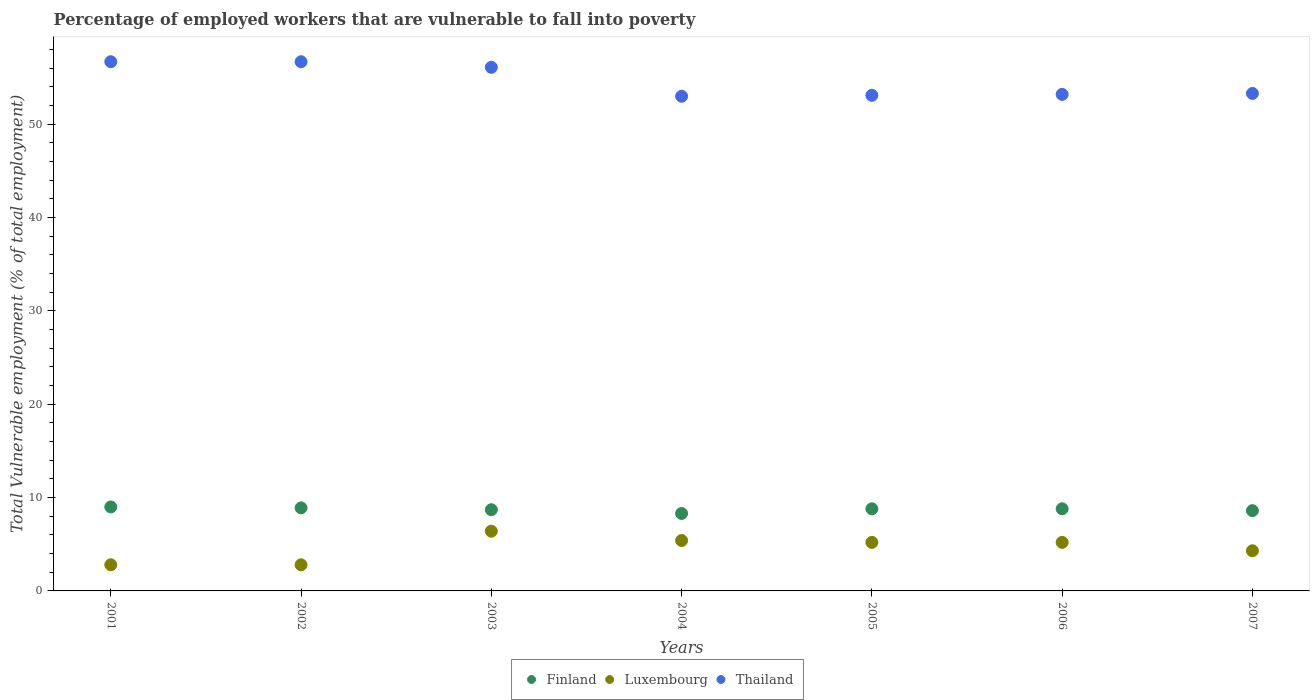How many different coloured dotlines are there?
Provide a succinct answer. 3. Is the number of dotlines equal to the number of legend labels?
Offer a terse response. Yes. What is the percentage of employed workers who are vulnerable to fall into poverty in Luxembourg in 2005?
Give a very brief answer. 5.2. Across all years, what is the maximum percentage of employed workers who are vulnerable to fall into poverty in Thailand?
Give a very brief answer. 56.7. Across all years, what is the minimum percentage of employed workers who are vulnerable to fall into poverty in Finland?
Your answer should be very brief. 8.3. What is the total percentage of employed workers who are vulnerable to fall into poverty in Luxembourg in the graph?
Ensure brevity in your answer.  32.1. What is the difference between the percentage of employed workers who are vulnerable to fall into poverty in Luxembourg in 2004 and that in 2005?
Your response must be concise. 0.2. What is the difference between the percentage of employed workers who are vulnerable to fall into poverty in Thailand in 2006 and the percentage of employed workers who are vulnerable to fall into poverty in Luxembourg in 2002?
Your response must be concise. 50.4. What is the average percentage of employed workers who are vulnerable to fall into poverty in Thailand per year?
Your answer should be compact. 54.59. In the year 2005, what is the difference between the percentage of employed workers who are vulnerable to fall into poverty in Thailand and percentage of employed workers who are vulnerable to fall into poverty in Luxembourg?
Make the answer very short. 47.9. What is the ratio of the percentage of employed workers who are vulnerable to fall into poverty in Thailand in 2006 to that in 2007?
Your answer should be very brief. 1. Is the difference between the percentage of employed workers who are vulnerable to fall into poverty in Thailand in 2001 and 2007 greater than the difference between the percentage of employed workers who are vulnerable to fall into poverty in Luxembourg in 2001 and 2007?
Offer a very short reply. Yes. What is the difference between the highest and the second highest percentage of employed workers who are vulnerable to fall into poverty in Luxembourg?
Provide a short and direct response. 1. What is the difference between the highest and the lowest percentage of employed workers who are vulnerable to fall into poverty in Thailand?
Offer a terse response. 3.7. Is the sum of the percentage of employed workers who are vulnerable to fall into poverty in Finland in 2002 and 2004 greater than the maximum percentage of employed workers who are vulnerable to fall into poverty in Thailand across all years?
Provide a short and direct response. No. Is the percentage of employed workers who are vulnerable to fall into poverty in Finland strictly greater than the percentage of employed workers who are vulnerable to fall into poverty in Thailand over the years?
Ensure brevity in your answer.  No. Is the percentage of employed workers who are vulnerable to fall into poverty in Thailand strictly less than the percentage of employed workers who are vulnerable to fall into poverty in Finland over the years?
Your answer should be compact. No. How many years are there in the graph?
Your response must be concise. 7. Are the values on the major ticks of Y-axis written in scientific E-notation?
Give a very brief answer. No. Does the graph contain any zero values?
Your answer should be compact. No. Does the graph contain grids?
Offer a terse response. No. Where does the legend appear in the graph?
Your answer should be very brief. Bottom center. How many legend labels are there?
Give a very brief answer. 3. What is the title of the graph?
Give a very brief answer. Percentage of employed workers that are vulnerable to fall into poverty. Does "Liberia" appear as one of the legend labels in the graph?
Your response must be concise. No. What is the label or title of the Y-axis?
Your answer should be compact. Total Vulnerable employment (% of total employment). What is the Total Vulnerable employment (% of total employment) of Finland in 2001?
Your answer should be compact. 9. What is the Total Vulnerable employment (% of total employment) in Luxembourg in 2001?
Keep it short and to the point. 2.8. What is the Total Vulnerable employment (% of total employment) in Thailand in 2001?
Provide a succinct answer. 56.7. What is the Total Vulnerable employment (% of total employment) in Finland in 2002?
Provide a succinct answer. 8.9. What is the Total Vulnerable employment (% of total employment) of Luxembourg in 2002?
Provide a short and direct response. 2.8. What is the Total Vulnerable employment (% of total employment) of Thailand in 2002?
Your response must be concise. 56.7. What is the Total Vulnerable employment (% of total employment) in Finland in 2003?
Offer a terse response. 8.7. What is the Total Vulnerable employment (% of total employment) in Luxembourg in 2003?
Your answer should be very brief. 6.4. What is the Total Vulnerable employment (% of total employment) of Thailand in 2003?
Offer a very short reply. 56.1. What is the Total Vulnerable employment (% of total employment) in Finland in 2004?
Your response must be concise. 8.3. What is the Total Vulnerable employment (% of total employment) in Luxembourg in 2004?
Your answer should be very brief. 5.4. What is the Total Vulnerable employment (% of total employment) of Finland in 2005?
Keep it short and to the point. 8.8. What is the Total Vulnerable employment (% of total employment) of Luxembourg in 2005?
Offer a terse response. 5.2. What is the Total Vulnerable employment (% of total employment) in Thailand in 2005?
Offer a terse response. 53.1. What is the Total Vulnerable employment (% of total employment) of Finland in 2006?
Your answer should be compact. 8.8. What is the Total Vulnerable employment (% of total employment) in Luxembourg in 2006?
Offer a terse response. 5.2. What is the Total Vulnerable employment (% of total employment) of Thailand in 2006?
Give a very brief answer. 53.2. What is the Total Vulnerable employment (% of total employment) of Finland in 2007?
Your response must be concise. 8.6. What is the Total Vulnerable employment (% of total employment) in Luxembourg in 2007?
Offer a terse response. 4.3. What is the Total Vulnerable employment (% of total employment) of Thailand in 2007?
Keep it short and to the point. 53.3. Across all years, what is the maximum Total Vulnerable employment (% of total employment) of Finland?
Your answer should be very brief. 9. Across all years, what is the maximum Total Vulnerable employment (% of total employment) of Luxembourg?
Offer a terse response. 6.4. Across all years, what is the maximum Total Vulnerable employment (% of total employment) in Thailand?
Provide a short and direct response. 56.7. Across all years, what is the minimum Total Vulnerable employment (% of total employment) in Finland?
Keep it short and to the point. 8.3. Across all years, what is the minimum Total Vulnerable employment (% of total employment) of Luxembourg?
Make the answer very short. 2.8. What is the total Total Vulnerable employment (% of total employment) of Finland in the graph?
Give a very brief answer. 61.1. What is the total Total Vulnerable employment (% of total employment) in Luxembourg in the graph?
Offer a terse response. 32.1. What is the total Total Vulnerable employment (% of total employment) in Thailand in the graph?
Your answer should be very brief. 382.1. What is the difference between the Total Vulnerable employment (% of total employment) in Luxembourg in 2001 and that in 2002?
Give a very brief answer. 0. What is the difference between the Total Vulnerable employment (% of total employment) of Thailand in 2001 and that in 2002?
Give a very brief answer. 0. What is the difference between the Total Vulnerable employment (% of total employment) of Finland in 2001 and that in 2003?
Ensure brevity in your answer.  0.3. What is the difference between the Total Vulnerable employment (% of total employment) in Luxembourg in 2001 and that in 2003?
Your answer should be very brief. -3.6. What is the difference between the Total Vulnerable employment (% of total employment) of Finland in 2001 and that in 2004?
Provide a succinct answer. 0.7. What is the difference between the Total Vulnerable employment (% of total employment) in Finland in 2001 and that in 2005?
Ensure brevity in your answer.  0.2. What is the difference between the Total Vulnerable employment (% of total employment) in Luxembourg in 2001 and that in 2005?
Your answer should be compact. -2.4. What is the difference between the Total Vulnerable employment (% of total employment) in Luxembourg in 2001 and that in 2006?
Keep it short and to the point. -2.4. What is the difference between the Total Vulnerable employment (% of total employment) of Thailand in 2001 and that in 2006?
Your answer should be very brief. 3.5. What is the difference between the Total Vulnerable employment (% of total employment) of Luxembourg in 2001 and that in 2007?
Give a very brief answer. -1.5. What is the difference between the Total Vulnerable employment (% of total employment) in Finland in 2002 and that in 2003?
Your answer should be very brief. 0.2. What is the difference between the Total Vulnerable employment (% of total employment) in Luxembourg in 2002 and that in 2003?
Your response must be concise. -3.6. What is the difference between the Total Vulnerable employment (% of total employment) in Thailand in 2002 and that in 2003?
Make the answer very short. 0.6. What is the difference between the Total Vulnerable employment (% of total employment) of Finland in 2002 and that in 2005?
Offer a very short reply. 0.1. What is the difference between the Total Vulnerable employment (% of total employment) of Luxembourg in 2002 and that in 2005?
Your answer should be very brief. -2.4. What is the difference between the Total Vulnerable employment (% of total employment) of Thailand in 2002 and that in 2005?
Make the answer very short. 3.6. What is the difference between the Total Vulnerable employment (% of total employment) of Finland in 2002 and that in 2006?
Provide a short and direct response. 0.1. What is the difference between the Total Vulnerable employment (% of total employment) in Thailand in 2002 and that in 2006?
Offer a very short reply. 3.5. What is the difference between the Total Vulnerable employment (% of total employment) in Finland in 2002 and that in 2007?
Your answer should be very brief. 0.3. What is the difference between the Total Vulnerable employment (% of total employment) of Thailand in 2003 and that in 2004?
Offer a terse response. 3.1. What is the difference between the Total Vulnerable employment (% of total employment) of Luxembourg in 2003 and that in 2005?
Your answer should be compact. 1.2. What is the difference between the Total Vulnerable employment (% of total employment) in Luxembourg in 2003 and that in 2006?
Offer a terse response. 1.2. What is the difference between the Total Vulnerable employment (% of total employment) of Thailand in 2003 and that in 2006?
Provide a succinct answer. 2.9. What is the difference between the Total Vulnerable employment (% of total employment) of Finland in 2003 and that in 2007?
Your response must be concise. 0.1. What is the difference between the Total Vulnerable employment (% of total employment) of Luxembourg in 2003 and that in 2007?
Give a very brief answer. 2.1. What is the difference between the Total Vulnerable employment (% of total employment) in Finland in 2004 and that in 2005?
Make the answer very short. -0.5. What is the difference between the Total Vulnerable employment (% of total employment) of Luxembourg in 2004 and that in 2005?
Your answer should be compact. 0.2. What is the difference between the Total Vulnerable employment (% of total employment) of Thailand in 2004 and that in 2005?
Your answer should be compact. -0.1. What is the difference between the Total Vulnerable employment (% of total employment) of Finland in 2004 and that in 2006?
Your response must be concise. -0.5. What is the difference between the Total Vulnerable employment (% of total employment) in Luxembourg in 2004 and that in 2006?
Provide a short and direct response. 0.2. What is the difference between the Total Vulnerable employment (% of total employment) of Thailand in 2004 and that in 2007?
Make the answer very short. -0.3. What is the difference between the Total Vulnerable employment (% of total employment) in Finland in 2005 and that in 2006?
Provide a succinct answer. 0. What is the difference between the Total Vulnerable employment (% of total employment) of Thailand in 2005 and that in 2006?
Your answer should be very brief. -0.1. What is the difference between the Total Vulnerable employment (% of total employment) of Finland in 2005 and that in 2007?
Provide a succinct answer. 0.2. What is the difference between the Total Vulnerable employment (% of total employment) of Thailand in 2005 and that in 2007?
Your response must be concise. -0.2. What is the difference between the Total Vulnerable employment (% of total employment) in Finland in 2006 and that in 2007?
Provide a succinct answer. 0.2. What is the difference between the Total Vulnerable employment (% of total employment) in Thailand in 2006 and that in 2007?
Give a very brief answer. -0.1. What is the difference between the Total Vulnerable employment (% of total employment) in Finland in 2001 and the Total Vulnerable employment (% of total employment) in Thailand in 2002?
Give a very brief answer. -47.7. What is the difference between the Total Vulnerable employment (% of total employment) of Luxembourg in 2001 and the Total Vulnerable employment (% of total employment) of Thailand in 2002?
Offer a very short reply. -53.9. What is the difference between the Total Vulnerable employment (% of total employment) of Finland in 2001 and the Total Vulnerable employment (% of total employment) of Thailand in 2003?
Offer a very short reply. -47.1. What is the difference between the Total Vulnerable employment (% of total employment) in Luxembourg in 2001 and the Total Vulnerable employment (% of total employment) in Thailand in 2003?
Keep it short and to the point. -53.3. What is the difference between the Total Vulnerable employment (% of total employment) of Finland in 2001 and the Total Vulnerable employment (% of total employment) of Thailand in 2004?
Provide a short and direct response. -44. What is the difference between the Total Vulnerable employment (% of total employment) of Luxembourg in 2001 and the Total Vulnerable employment (% of total employment) of Thailand in 2004?
Give a very brief answer. -50.2. What is the difference between the Total Vulnerable employment (% of total employment) of Finland in 2001 and the Total Vulnerable employment (% of total employment) of Luxembourg in 2005?
Provide a succinct answer. 3.8. What is the difference between the Total Vulnerable employment (% of total employment) of Finland in 2001 and the Total Vulnerable employment (% of total employment) of Thailand in 2005?
Give a very brief answer. -44.1. What is the difference between the Total Vulnerable employment (% of total employment) of Luxembourg in 2001 and the Total Vulnerable employment (% of total employment) of Thailand in 2005?
Your answer should be very brief. -50.3. What is the difference between the Total Vulnerable employment (% of total employment) of Finland in 2001 and the Total Vulnerable employment (% of total employment) of Thailand in 2006?
Ensure brevity in your answer.  -44.2. What is the difference between the Total Vulnerable employment (% of total employment) in Luxembourg in 2001 and the Total Vulnerable employment (% of total employment) in Thailand in 2006?
Your answer should be compact. -50.4. What is the difference between the Total Vulnerable employment (% of total employment) in Finland in 2001 and the Total Vulnerable employment (% of total employment) in Luxembourg in 2007?
Provide a short and direct response. 4.7. What is the difference between the Total Vulnerable employment (% of total employment) in Finland in 2001 and the Total Vulnerable employment (% of total employment) in Thailand in 2007?
Your answer should be compact. -44.3. What is the difference between the Total Vulnerable employment (% of total employment) of Luxembourg in 2001 and the Total Vulnerable employment (% of total employment) of Thailand in 2007?
Your answer should be very brief. -50.5. What is the difference between the Total Vulnerable employment (% of total employment) of Finland in 2002 and the Total Vulnerable employment (% of total employment) of Thailand in 2003?
Ensure brevity in your answer.  -47.2. What is the difference between the Total Vulnerable employment (% of total employment) of Luxembourg in 2002 and the Total Vulnerable employment (% of total employment) of Thailand in 2003?
Offer a very short reply. -53.3. What is the difference between the Total Vulnerable employment (% of total employment) of Finland in 2002 and the Total Vulnerable employment (% of total employment) of Luxembourg in 2004?
Make the answer very short. 3.5. What is the difference between the Total Vulnerable employment (% of total employment) in Finland in 2002 and the Total Vulnerable employment (% of total employment) in Thailand in 2004?
Provide a short and direct response. -44.1. What is the difference between the Total Vulnerable employment (% of total employment) of Luxembourg in 2002 and the Total Vulnerable employment (% of total employment) of Thailand in 2004?
Keep it short and to the point. -50.2. What is the difference between the Total Vulnerable employment (% of total employment) in Finland in 2002 and the Total Vulnerable employment (% of total employment) in Luxembourg in 2005?
Ensure brevity in your answer.  3.7. What is the difference between the Total Vulnerable employment (% of total employment) in Finland in 2002 and the Total Vulnerable employment (% of total employment) in Thailand in 2005?
Your answer should be compact. -44.2. What is the difference between the Total Vulnerable employment (% of total employment) in Luxembourg in 2002 and the Total Vulnerable employment (% of total employment) in Thailand in 2005?
Your answer should be compact. -50.3. What is the difference between the Total Vulnerable employment (% of total employment) of Finland in 2002 and the Total Vulnerable employment (% of total employment) of Luxembourg in 2006?
Your answer should be very brief. 3.7. What is the difference between the Total Vulnerable employment (% of total employment) of Finland in 2002 and the Total Vulnerable employment (% of total employment) of Thailand in 2006?
Make the answer very short. -44.3. What is the difference between the Total Vulnerable employment (% of total employment) of Luxembourg in 2002 and the Total Vulnerable employment (% of total employment) of Thailand in 2006?
Ensure brevity in your answer.  -50.4. What is the difference between the Total Vulnerable employment (% of total employment) in Finland in 2002 and the Total Vulnerable employment (% of total employment) in Thailand in 2007?
Your response must be concise. -44.4. What is the difference between the Total Vulnerable employment (% of total employment) in Luxembourg in 2002 and the Total Vulnerable employment (% of total employment) in Thailand in 2007?
Provide a short and direct response. -50.5. What is the difference between the Total Vulnerable employment (% of total employment) of Finland in 2003 and the Total Vulnerable employment (% of total employment) of Luxembourg in 2004?
Your answer should be very brief. 3.3. What is the difference between the Total Vulnerable employment (% of total employment) of Finland in 2003 and the Total Vulnerable employment (% of total employment) of Thailand in 2004?
Keep it short and to the point. -44.3. What is the difference between the Total Vulnerable employment (% of total employment) of Luxembourg in 2003 and the Total Vulnerable employment (% of total employment) of Thailand in 2004?
Keep it short and to the point. -46.6. What is the difference between the Total Vulnerable employment (% of total employment) of Finland in 2003 and the Total Vulnerable employment (% of total employment) of Luxembourg in 2005?
Your answer should be compact. 3.5. What is the difference between the Total Vulnerable employment (% of total employment) of Finland in 2003 and the Total Vulnerable employment (% of total employment) of Thailand in 2005?
Offer a terse response. -44.4. What is the difference between the Total Vulnerable employment (% of total employment) in Luxembourg in 2003 and the Total Vulnerable employment (% of total employment) in Thailand in 2005?
Provide a short and direct response. -46.7. What is the difference between the Total Vulnerable employment (% of total employment) of Finland in 2003 and the Total Vulnerable employment (% of total employment) of Luxembourg in 2006?
Your response must be concise. 3.5. What is the difference between the Total Vulnerable employment (% of total employment) of Finland in 2003 and the Total Vulnerable employment (% of total employment) of Thailand in 2006?
Keep it short and to the point. -44.5. What is the difference between the Total Vulnerable employment (% of total employment) of Luxembourg in 2003 and the Total Vulnerable employment (% of total employment) of Thailand in 2006?
Offer a very short reply. -46.8. What is the difference between the Total Vulnerable employment (% of total employment) in Finland in 2003 and the Total Vulnerable employment (% of total employment) in Luxembourg in 2007?
Provide a succinct answer. 4.4. What is the difference between the Total Vulnerable employment (% of total employment) in Finland in 2003 and the Total Vulnerable employment (% of total employment) in Thailand in 2007?
Ensure brevity in your answer.  -44.6. What is the difference between the Total Vulnerable employment (% of total employment) in Luxembourg in 2003 and the Total Vulnerable employment (% of total employment) in Thailand in 2007?
Offer a terse response. -46.9. What is the difference between the Total Vulnerable employment (% of total employment) in Finland in 2004 and the Total Vulnerable employment (% of total employment) in Luxembourg in 2005?
Provide a short and direct response. 3.1. What is the difference between the Total Vulnerable employment (% of total employment) of Finland in 2004 and the Total Vulnerable employment (% of total employment) of Thailand in 2005?
Provide a succinct answer. -44.8. What is the difference between the Total Vulnerable employment (% of total employment) of Luxembourg in 2004 and the Total Vulnerable employment (% of total employment) of Thailand in 2005?
Your answer should be very brief. -47.7. What is the difference between the Total Vulnerable employment (% of total employment) of Finland in 2004 and the Total Vulnerable employment (% of total employment) of Thailand in 2006?
Offer a terse response. -44.9. What is the difference between the Total Vulnerable employment (% of total employment) of Luxembourg in 2004 and the Total Vulnerable employment (% of total employment) of Thailand in 2006?
Keep it short and to the point. -47.8. What is the difference between the Total Vulnerable employment (% of total employment) of Finland in 2004 and the Total Vulnerable employment (% of total employment) of Luxembourg in 2007?
Give a very brief answer. 4. What is the difference between the Total Vulnerable employment (% of total employment) in Finland in 2004 and the Total Vulnerable employment (% of total employment) in Thailand in 2007?
Give a very brief answer. -45. What is the difference between the Total Vulnerable employment (% of total employment) of Luxembourg in 2004 and the Total Vulnerable employment (% of total employment) of Thailand in 2007?
Your response must be concise. -47.9. What is the difference between the Total Vulnerable employment (% of total employment) in Finland in 2005 and the Total Vulnerable employment (% of total employment) in Luxembourg in 2006?
Offer a very short reply. 3.6. What is the difference between the Total Vulnerable employment (% of total employment) in Finland in 2005 and the Total Vulnerable employment (% of total employment) in Thailand in 2006?
Make the answer very short. -44.4. What is the difference between the Total Vulnerable employment (% of total employment) of Luxembourg in 2005 and the Total Vulnerable employment (% of total employment) of Thailand in 2006?
Provide a short and direct response. -48. What is the difference between the Total Vulnerable employment (% of total employment) in Finland in 2005 and the Total Vulnerable employment (% of total employment) in Thailand in 2007?
Your answer should be very brief. -44.5. What is the difference between the Total Vulnerable employment (% of total employment) in Luxembourg in 2005 and the Total Vulnerable employment (% of total employment) in Thailand in 2007?
Offer a terse response. -48.1. What is the difference between the Total Vulnerable employment (% of total employment) of Finland in 2006 and the Total Vulnerable employment (% of total employment) of Thailand in 2007?
Offer a terse response. -44.5. What is the difference between the Total Vulnerable employment (% of total employment) of Luxembourg in 2006 and the Total Vulnerable employment (% of total employment) of Thailand in 2007?
Give a very brief answer. -48.1. What is the average Total Vulnerable employment (% of total employment) in Finland per year?
Your response must be concise. 8.73. What is the average Total Vulnerable employment (% of total employment) in Luxembourg per year?
Offer a very short reply. 4.59. What is the average Total Vulnerable employment (% of total employment) in Thailand per year?
Make the answer very short. 54.59. In the year 2001, what is the difference between the Total Vulnerable employment (% of total employment) of Finland and Total Vulnerable employment (% of total employment) of Thailand?
Keep it short and to the point. -47.7. In the year 2001, what is the difference between the Total Vulnerable employment (% of total employment) in Luxembourg and Total Vulnerable employment (% of total employment) in Thailand?
Keep it short and to the point. -53.9. In the year 2002, what is the difference between the Total Vulnerable employment (% of total employment) of Finland and Total Vulnerable employment (% of total employment) of Luxembourg?
Offer a very short reply. 6.1. In the year 2002, what is the difference between the Total Vulnerable employment (% of total employment) of Finland and Total Vulnerable employment (% of total employment) of Thailand?
Keep it short and to the point. -47.8. In the year 2002, what is the difference between the Total Vulnerable employment (% of total employment) in Luxembourg and Total Vulnerable employment (% of total employment) in Thailand?
Ensure brevity in your answer.  -53.9. In the year 2003, what is the difference between the Total Vulnerable employment (% of total employment) of Finland and Total Vulnerable employment (% of total employment) of Thailand?
Make the answer very short. -47.4. In the year 2003, what is the difference between the Total Vulnerable employment (% of total employment) in Luxembourg and Total Vulnerable employment (% of total employment) in Thailand?
Your answer should be very brief. -49.7. In the year 2004, what is the difference between the Total Vulnerable employment (% of total employment) of Finland and Total Vulnerable employment (% of total employment) of Thailand?
Provide a succinct answer. -44.7. In the year 2004, what is the difference between the Total Vulnerable employment (% of total employment) in Luxembourg and Total Vulnerable employment (% of total employment) in Thailand?
Offer a very short reply. -47.6. In the year 2005, what is the difference between the Total Vulnerable employment (% of total employment) of Finland and Total Vulnerable employment (% of total employment) of Thailand?
Ensure brevity in your answer.  -44.3. In the year 2005, what is the difference between the Total Vulnerable employment (% of total employment) of Luxembourg and Total Vulnerable employment (% of total employment) of Thailand?
Ensure brevity in your answer.  -47.9. In the year 2006, what is the difference between the Total Vulnerable employment (% of total employment) in Finland and Total Vulnerable employment (% of total employment) in Thailand?
Keep it short and to the point. -44.4. In the year 2006, what is the difference between the Total Vulnerable employment (% of total employment) in Luxembourg and Total Vulnerable employment (% of total employment) in Thailand?
Provide a short and direct response. -48. In the year 2007, what is the difference between the Total Vulnerable employment (% of total employment) in Finland and Total Vulnerable employment (% of total employment) in Luxembourg?
Your answer should be compact. 4.3. In the year 2007, what is the difference between the Total Vulnerable employment (% of total employment) in Finland and Total Vulnerable employment (% of total employment) in Thailand?
Provide a succinct answer. -44.7. In the year 2007, what is the difference between the Total Vulnerable employment (% of total employment) in Luxembourg and Total Vulnerable employment (% of total employment) in Thailand?
Provide a succinct answer. -49. What is the ratio of the Total Vulnerable employment (% of total employment) of Finland in 2001 to that in 2002?
Give a very brief answer. 1.01. What is the ratio of the Total Vulnerable employment (% of total employment) in Thailand in 2001 to that in 2002?
Your response must be concise. 1. What is the ratio of the Total Vulnerable employment (% of total employment) of Finland in 2001 to that in 2003?
Offer a terse response. 1.03. What is the ratio of the Total Vulnerable employment (% of total employment) of Luxembourg in 2001 to that in 2003?
Keep it short and to the point. 0.44. What is the ratio of the Total Vulnerable employment (% of total employment) in Thailand in 2001 to that in 2003?
Offer a terse response. 1.01. What is the ratio of the Total Vulnerable employment (% of total employment) of Finland in 2001 to that in 2004?
Your answer should be compact. 1.08. What is the ratio of the Total Vulnerable employment (% of total employment) in Luxembourg in 2001 to that in 2004?
Make the answer very short. 0.52. What is the ratio of the Total Vulnerable employment (% of total employment) of Thailand in 2001 to that in 2004?
Your answer should be very brief. 1.07. What is the ratio of the Total Vulnerable employment (% of total employment) of Finland in 2001 to that in 2005?
Make the answer very short. 1.02. What is the ratio of the Total Vulnerable employment (% of total employment) in Luxembourg in 2001 to that in 2005?
Your response must be concise. 0.54. What is the ratio of the Total Vulnerable employment (% of total employment) of Thailand in 2001 to that in 2005?
Your response must be concise. 1.07. What is the ratio of the Total Vulnerable employment (% of total employment) of Finland in 2001 to that in 2006?
Make the answer very short. 1.02. What is the ratio of the Total Vulnerable employment (% of total employment) of Luxembourg in 2001 to that in 2006?
Keep it short and to the point. 0.54. What is the ratio of the Total Vulnerable employment (% of total employment) of Thailand in 2001 to that in 2006?
Provide a succinct answer. 1.07. What is the ratio of the Total Vulnerable employment (% of total employment) of Finland in 2001 to that in 2007?
Make the answer very short. 1.05. What is the ratio of the Total Vulnerable employment (% of total employment) of Luxembourg in 2001 to that in 2007?
Your response must be concise. 0.65. What is the ratio of the Total Vulnerable employment (% of total employment) of Thailand in 2001 to that in 2007?
Ensure brevity in your answer.  1.06. What is the ratio of the Total Vulnerable employment (% of total employment) of Luxembourg in 2002 to that in 2003?
Offer a terse response. 0.44. What is the ratio of the Total Vulnerable employment (% of total employment) of Thailand in 2002 to that in 2003?
Offer a terse response. 1.01. What is the ratio of the Total Vulnerable employment (% of total employment) in Finland in 2002 to that in 2004?
Give a very brief answer. 1.07. What is the ratio of the Total Vulnerable employment (% of total employment) in Luxembourg in 2002 to that in 2004?
Make the answer very short. 0.52. What is the ratio of the Total Vulnerable employment (% of total employment) in Thailand in 2002 to that in 2004?
Ensure brevity in your answer.  1.07. What is the ratio of the Total Vulnerable employment (% of total employment) in Finland in 2002 to that in 2005?
Provide a short and direct response. 1.01. What is the ratio of the Total Vulnerable employment (% of total employment) in Luxembourg in 2002 to that in 2005?
Provide a succinct answer. 0.54. What is the ratio of the Total Vulnerable employment (% of total employment) in Thailand in 2002 to that in 2005?
Offer a terse response. 1.07. What is the ratio of the Total Vulnerable employment (% of total employment) in Finland in 2002 to that in 2006?
Keep it short and to the point. 1.01. What is the ratio of the Total Vulnerable employment (% of total employment) in Luxembourg in 2002 to that in 2006?
Offer a very short reply. 0.54. What is the ratio of the Total Vulnerable employment (% of total employment) of Thailand in 2002 to that in 2006?
Provide a short and direct response. 1.07. What is the ratio of the Total Vulnerable employment (% of total employment) of Finland in 2002 to that in 2007?
Offer a terse response. 1.03. What is the ratio of the Total Vulnerable employment (% of total employment) of Luxembourg in 2002 to that in 2007?
Provide a short and direct response. 0.65. What is the ratio of the Total Vulnerable employment (% of total employment) of Thailand in 2002 to that in 2007?
Provide a succinct answer. 1.06. What is the ratio of the Total Vulnerable employment (% of total employment) in Finland in 2003 to that in 2004?
Make the answer very short. 1.05. What is the ratio of the Total Vulnerable employment (% of total employment) in Luxembourg in 2003 to that in 2004?
Offer a very short reply. 1.19. What is the ratio of the Total Vulnerable employment (% of total employment) of Thailand in 2003 to that in 2004?
Provide a succinct answer. 1.06. What is the ratio of the Total Vulnerable employment (% of total employment) of Finland in 2003 to that in 2005?
Offer a terse response. 0.99. What is the ratio of the Total Vulnerable employment (% of total employment) of Luxembourg in 2003 to that in 2005?
Provide a short and direct response. 1.23. What is the ratio of the Total Vulnerable employment (% of total employment) of Thailand in 2003 to that in 2005?
Provide a succinct answer. 1.06. What is the ratio of the Total Vulnerable employment (% of total employment) in Finland in 2003 to that in 2006?
Make the answer very short. 0.99. What is the ratio of the Total Vulnerable employment (% of total employment) of Luxembourg in 2003 to that in 2006?
Give a very brief answer. 1.23. What is the ratio of the Total Vulnerable employment (% of total employment) in Thailand in 2003 to that in 2006?
Give a very brief answer. 1.05. What is the ratio of the Total Vulnerable employment (% of total employment) in Finland in 2003 to that in 2007?
Your answer should be compact. 1.01. What is the ratio of the Total Vulnerable employment (% of total employment) in Luxembourg in 2003 to that in 2007?
Your answer should be very brief. 1.49. What is the ratio of the Total Vulnerable employment (% of total employment) in Thailand in 2003 to that in 2007?
Your answer should be compact. 1.05. What is the ratio of the Total Vulnerable employment (% of total employment) in Finland in 2004 to that in 2005?
Offer a very short reply. 0.94. What is the ratio of the Total Vulnerable employment (% of total employment) in Luxembourg in 2004 to that in 2005?
Your response must be concise. 1.04. What is the ratio of the Total Vulnerable employment (% of total employment) in Thailand in 2004 to that in 2005?
Make the answer very short. 1. What is the ratio of the Total Vulnerable employment (% of total employment) in Finland in 2004 to that in 2006?
Keep it short and to the point. 0.94. What is the ratio of the Total Vulnerable employment (% of total employment) of Luxembourg in 2004 to that in 2006?
Provide a succinct answer. 1.04. What is the ratio of the Total Vulnerable employment (% of total employment) in Thailand in 2004 to that in 2006?
Ensure brevity in your answer.  1. What is the ratio of the Total Vulnerable employment (% of total employment) of Finland in 2004 to that in 2007?
Your answer should be very brief. 0.97. What is the ratio of the Total Vulnerable employment (% of total employment) of Luxembourg in 2004 to that in 2007?
Make the answer very short. 1.26. What is the ratio of the Total Vulnerable employment (% of total employment) of Finland in 2005 to that in 2007?
Your response must be concise. 1.02. What is the ratio of the Total Vulnerable employment (% of total employment) of Luxembourg in 2005 to that in 2007?
Provide a short and direct response. 1.21. What is the ratio of the Total Vulnerable employment (% of total employment) of Finland in 2006 to that in 2007?
Your answer should be very brief. 1.02. What is the ratio of the Total Vulnerable employment (% of total employment) in Luxembourg in 2006 to that in 2007?
Provide a short and direct response. 1.21. What is the ratio of the Total Vulnerable employment (% of total employment) of Thailand in 2006 to that in 2007?
Ensure brevity in your answer.  1. What is the difference between the highest and the second highest Total Vulnerable employment (% of total employment) of Finland?
Offer a terse response. 0.1. What is the difference between the highest and the second highest Total Vulnerable employment (% of total employment) in Thailand?
Your answer should be compact. 0. What is the difference between the highest and the lowest Total Vulnerable employment (% of total employment) of Finland?
Your answer should be very brief. 0.7. What is the difference between the highest and the lowest Total Vulnerable employment (% of total employment) of Luxembourg?
Provide a short and direct response. 3.6. What is the difference between the highest and the lowest Total Vulnerable employment (% of total employment) in Thailand?
Give a very brief answer. 3.7. 